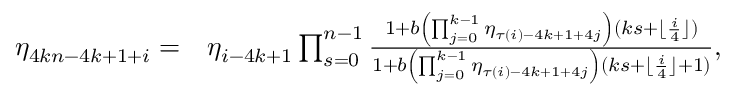<formula> <loc_0><loc_0><loc_500><loc_500>\begin{array} { r l } { \eta _ { 4 k n - 4 k + 1 + i } = } & { \eta _ { i - 4 k + 1 } \prod _ { s = 0 } ^ { n - 1 } \frac { 1 + b \left ( \prod _ { j = 0 } ^ { k - 1 } { \eta _ { \tau ( i ) - 4 k + 1 + 4 j } } \right ) ( k s + \lfloor \frac { i } { 4 } \rfloor ) } { 1 + b \left ( \prod _ { j = 0 } ^ { k - 1 } { \eta _ { \tau ( i ) - 4 k + 1 + 4 j } } \right ) ( k s + \lfloor \frac { i } { 4 } \rfloor + 1 ) } , } \end{array}</formula> 